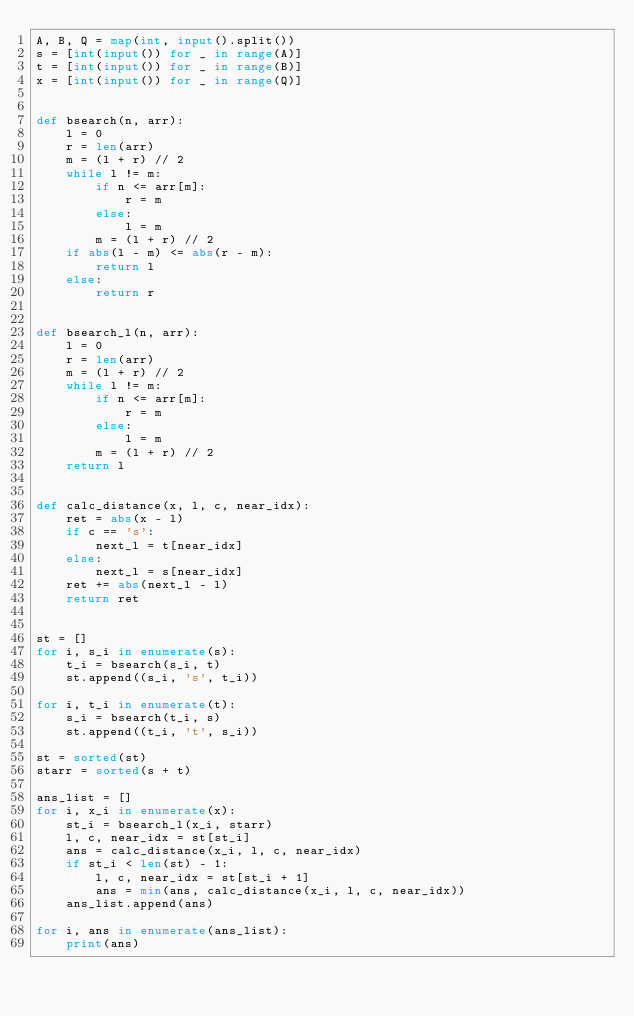Convert code to text. <code><loc_0><loc_0><loc_500><loc_500><_Python_>A, B, Q = map(int, input().split())
s = [int(input()) for _ in range(A)]
t = [int(input()) for _ in range(B)]
x = [int(input()) for _ in range(Q)]


def bsearch(n, arr):
    l = 0
    r = len(arr)
    m = (l + r) // 2
    while l != m:
        if n <= arr[m]:
            r = m
        else:
            l = m
        m = (l + r) // 2
    if abs(l - m) <= abs(r - m):
        return l
    else:
        return r


def bsearch_l(n, arr):
    l = 0
    r = len(arr)
    m = (l + r) // 2
    while l != m:
        if n <= arr[m]:
            r = m
        else:
            l = m
        m = (l + r) // 2
    return l


def calc_distance(x, l, c, near_idx):
    ret = abs(x - l)
    if c == 's':
        next_l = t[near_idx]
    else:
        next_l = s[near_idx]
    ret += abs(next_l - l)
    return ret


st = []
for i, s_i in enumerate(s):
    t_i = bsearch(s_i, t)
    st.append((s_i, 's', t_i))

for i, t_i in enumerate(t):
    s_i = bsearch(t_i, s)
    st.append((t_i, 't', s_i))

st = sorted(st)
starr = sorted(s + t)

ans_list = []
for i, x_i in enumerate(x):
    st_i = bsearch_l(x_i, starr)
    l, c, near_idx = st[st_i]
    ans = calc_distance(x_i, l, c, near_idx)
    if st_i < len(st) - 1:
        l, c, near_idx = st[st_i + 1]
        ans = min(ans, calc_distance(x_i, l, c, near_idx))
    ans_list.append(ans)

for i, ans in enumerate(ans_list):
    print(ans)</code> 